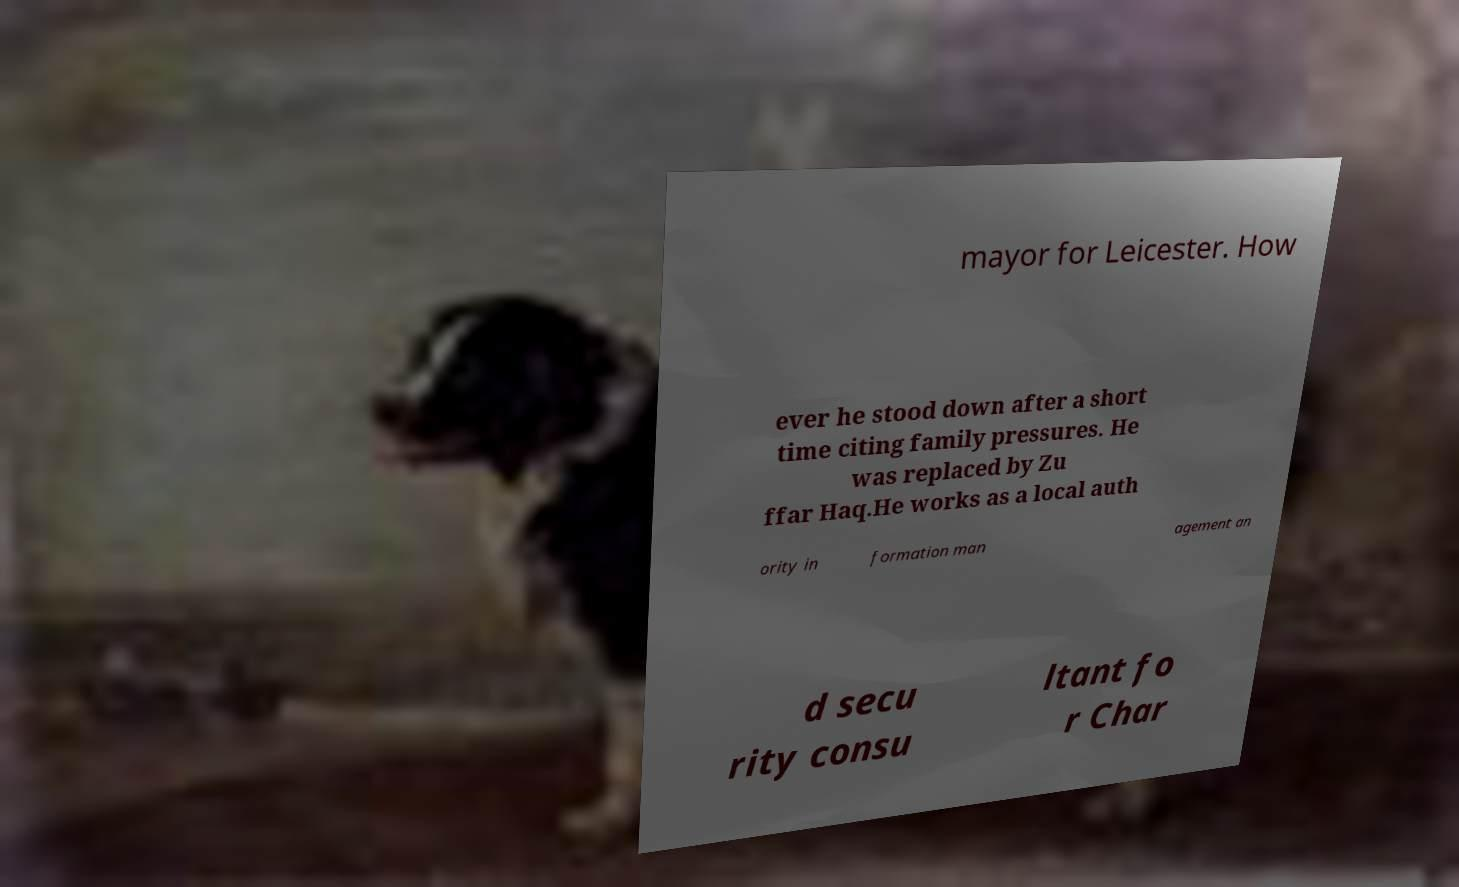Please read and relay the text visible in this image. What does it say? mayor for Leicester. How ever he stood down after a short time citing family pressures. He was replaced by Zu ffar Haq.He works as a local auth ority in formation man agement an d secu rity consu ltant fo r Char 